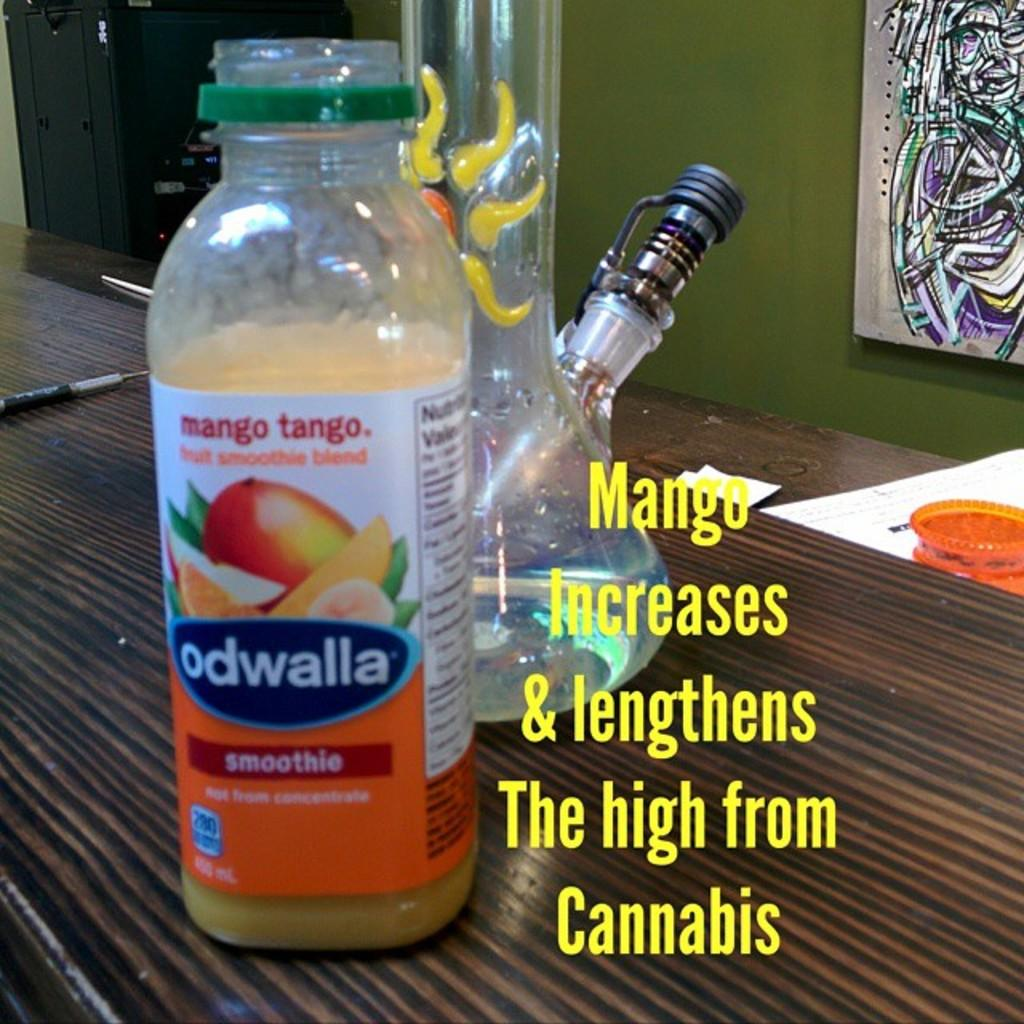<image>
Offer a succinct explanation of the picture presented. A bottle of Odwalla smoothie on a table next to a drinking glass. 